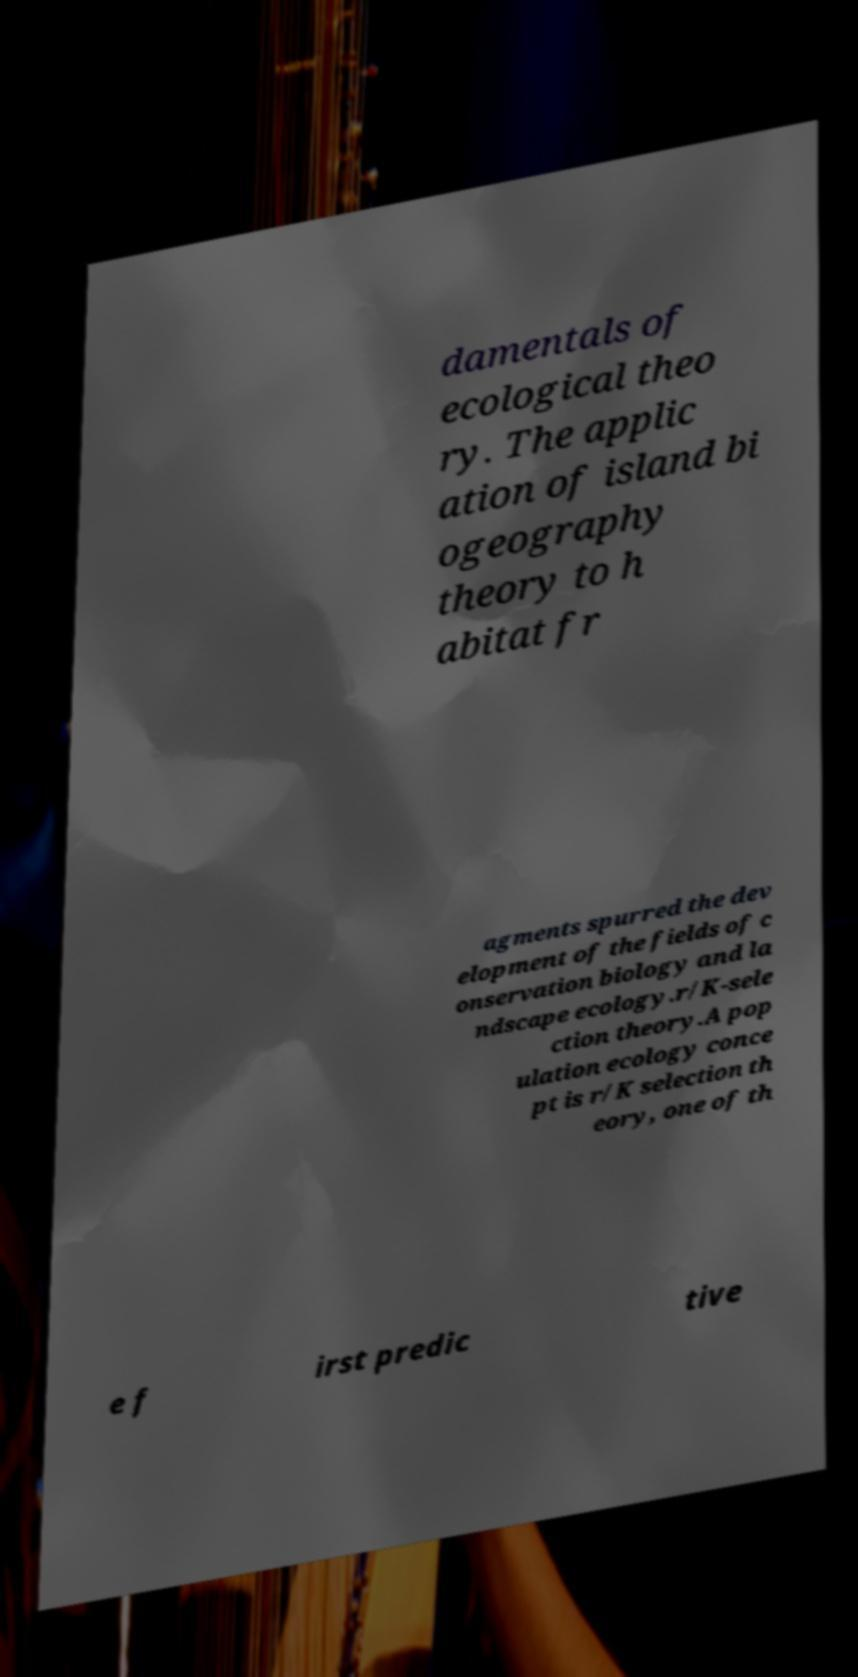What messages or text are displayed in this image? I need them in a readable, typed format. damentals of ecological theo ry. The applic ation of island bi ogeography theory to h abitat fr agments spurred the dev elopment of the fields of c onservation biology and la ndscape ecology.r/K-sele ction theory.A pop ulation ecology conce pt is r/K selection th eory, one of th e f irst predic tive 